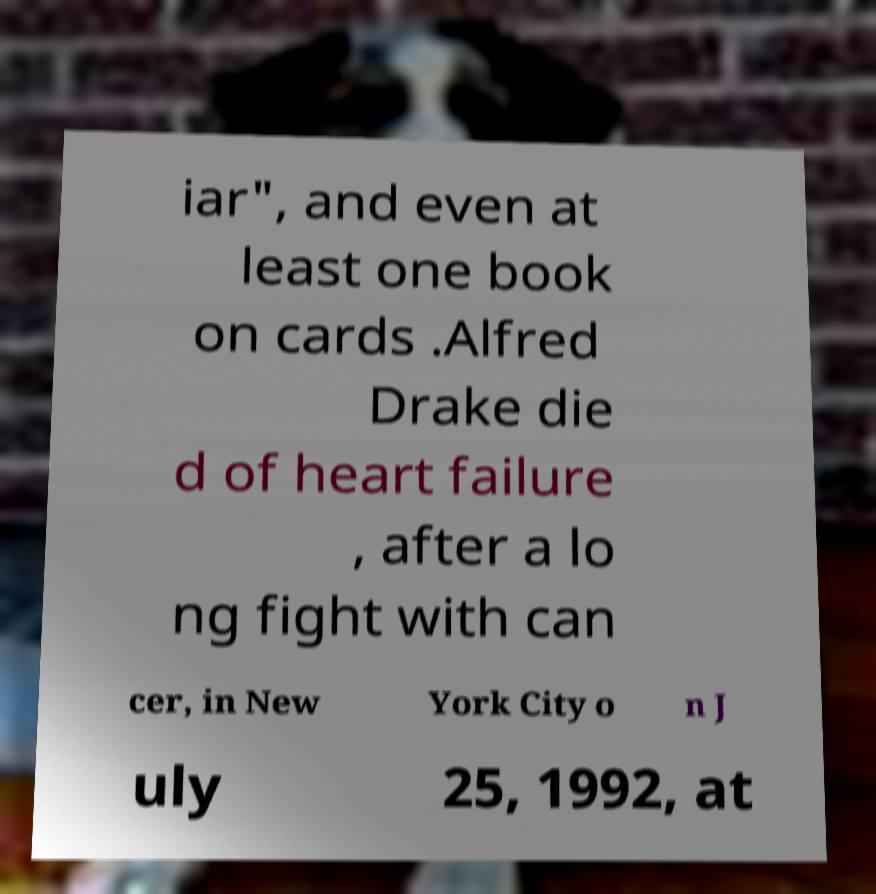There's text embedded in this image that I need extracted. Can you transcribe it verbatim? iar", and even at least one book on cards .Alfred Drake die d of heart failure , after a lo ng fight with can cer, in New York City o n J uly 25, 1992, at 